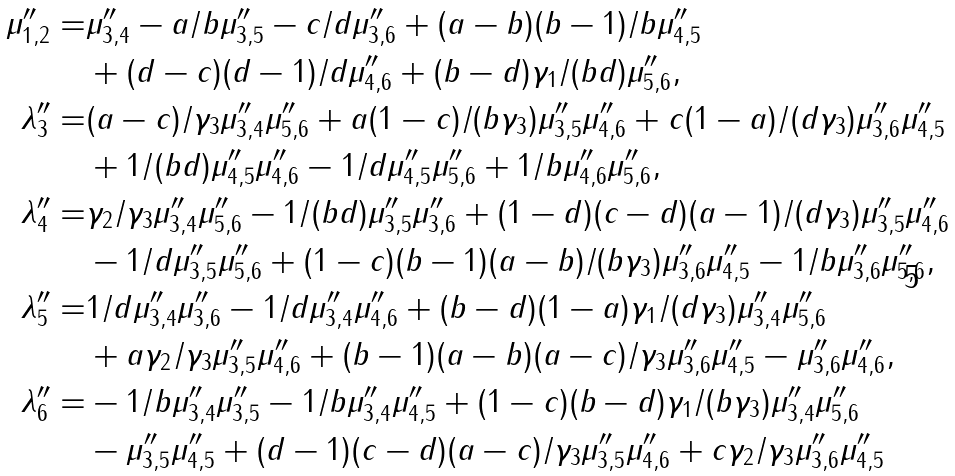<formula> <loc_0><loc_0><loc_500><loc_500>\mu ^ { \prime \prime } _ { 1 , 2 } = & \mu ^ { \prime \prime } _ { 3 , 4 } - a / b \mu ^ { \prime \prime } _ { 3 , 5 } - c / d \mu ^ { \prime \prime } _ { 3 , 6 } + ( a - b ) ( b - 1 ) / b \mu ^ { \prime \prime } _ { 4 , 5 } \\ & + ( d - c ) ( d - 1 ) / d \mu ^ { \prime \prime } _ { 4 , 6 } + ( b - d ) \gamma _ { 1 } / ( b d ) \mu ^ { \prime \prime } _ { 5 , 6 } , \\ \lambda ^ { \prime \prime } _ { 3 } = & ( a - c ) / \gamma _ { 3 } \mu ^ { \prime \prime } _ { 3 , 4 } \mu ^ { \prime \prime } _ { 5 , 6 } + a ( 1 - c ) / ( b \gamma _ { 3 } ) \mu ^ { \prime \prime } _ { 3 , 5 } \mu ^ { \prime \prime } _ { 4 , 6 } + c ( 1 - a ) / ( d \gamma _ { 3 } ) \mu ^ { \prime \prime } _ { 3 , 6 } \mu ^ { \prime \prime } _ { 4 , 5 } \\ & + 1 / ( b d ) \mu ^ { \prime \prime } _ { 4 , 5 } \mu ^ { \prime \prime } _ { 4 , 6 } - 1 / d \mu ^ { \prime \prime } _ { 4 , 5 } \mu ^ { \prime \prime } _ { 5 , 6 } + 1 / b \mu ^ { \prime \prime } _ { 4 , 6 } \mu ^ { \prime \prime } _ { 5 , 6 } , \\ \lambda ^ { \prime \prime } _ { 4 } = & \gamma _ { 2 } / \gamma _ { 3 } \mu ^ { \prime \prime } _ { 3 , 4 } \mu ^ { \prime \prime } _ { 5 , 6 } - 1 / ( b d ) \mu ^ { \prime \prime } _ { 3 , 5 } \mu ^ { \prime \prime } _ { 3 , 6 } + ( 1 - d ) ( c - d ) ( a - 1 ) / ( d \gamma _ { 3 } ) \mu ^ { \prime \prime } _ { 3 , 5 } \mu ^ { \prime \prime } _ { 4 , 6 } \\ & - 1 / d \mu ^ { \prime \prime } _ { 3 , 5 } \mu ^ { \prime \prime } _ { 5 , 6 } + ( 1 - c ) ( b - 1 ) ( a - b ) / ( b \gamma _ { 3 } ) \mu ^ { \prime \prime } _ { 3 , 6 } \mu ^ { \prime \prime } _ { 4 , 5 } - 1 / b \mu ^ { \prime \prime } _ { 3 , 6 } \mu ^ { \prime \prime } _ { 5 , 6 } , \\ \lambda ^ { \prime \prime } _ { 5 } = & 1 / d \mu ^ { \prime \prime } _ { 3 , 4 } \mu ^ { \prime \prime } _ { 3 , 6 } - 1 / d \mu ^ { \prime \prime } _ { 3 , 4 } \mu ^ { \prime \prime } _ { 4 , 6 } + ( b - d ) ( 1 - a ) \gamma _ { 1 } / ( d \gamma _ { 3 } ) \mu ^ { \prime \prime } _ { 3 , 4 } \mu ^ { \prime \prime } _ { 5 , 6 } \\ & + a \gamma _ { 2 } / \gamma _ { 3 } \mu ^ { \prime \prime } _ { 3 , 5 } \mu ^ { \prime \prime } _ { 4 , 6 } + ( b - 1 ) ( a - b ) ( a - c ) / \gamma _ { 3 } \mu ^ { \prime \prime } _ { 3 , 6 } \mu ^ { \prime \prime } _ { 4 , 5 } - \mu ^ { \prime \prime } _ { 3 , 6 } \mu ^ { \prime \prime } _ { 4 , 6 } , \\ \lambda ^ { \prime \prime } _ { 6 } = & - 1 / b \mu ^ { \prime \prime } _ { 3 , 4 } \mu ^ { \prime \prime } _ { 3 , 5 } - 1 / b \mu ^ { \prime \prime } _ { 3 , 4 } \mu ^ { \prime \prime } _ { 4 , 5 } + ( 1 - c ) ( b - d ) \gamma _ { 1 } / ( b \gamma _ { 3 } ) \mu ^ { \prime \prime } _ { 3 , 4 } \mu ^ { \prime \prime } _ { 5 , 6 } \\ & - \mu ^ { \prime \prime } _ { 3 , 5 } \mu ^ { \prime \prime } _ { 4 , 5 } + ( d - 1 ) ( c - d ) ( a - c ) / \gamma _ { 3 } \mu ^ { \prime \prime } _ { 3 , 5 } \mu ^ { \prime \prime } _ { 4 , 6 } + c \gamma _ { 2 } / \gamma _ { 3 } \mu ^ { \prime \prime } _ { 3 , 6 } \mu ^ { \prime \prime } _ { 4 , 5 }</formula> 